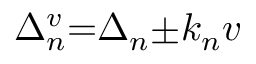<formula> <loc_0><loc_0><loc_500><loc_500>\Delta _ { n } ^ { v } { = } \Delta _ { n } { \pm } k _ { n } v</formula> 